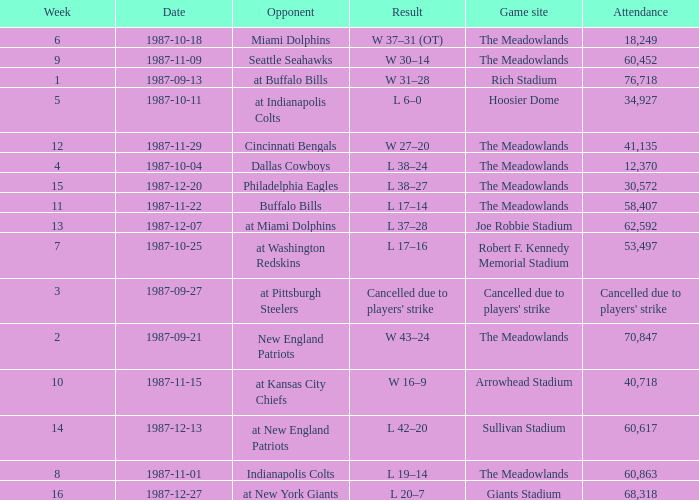Who did the Jets play in their pre-week 9 game at the Robert F. Kennedy memorial stadium? At washington redskins. 